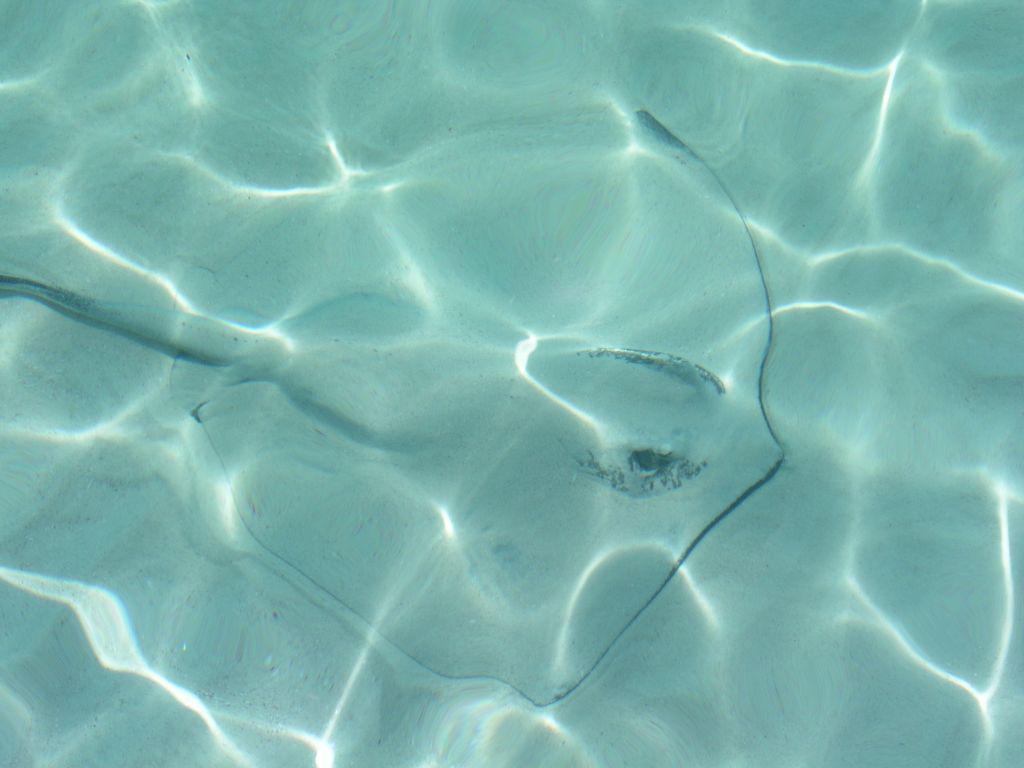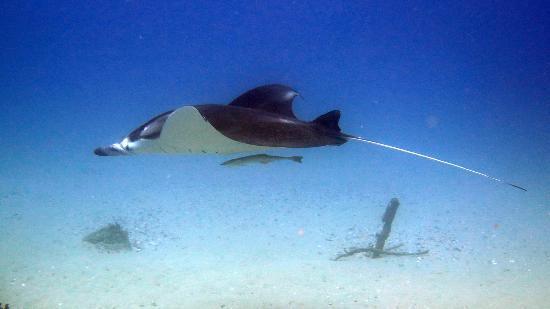The first image is the image on the left, the second image is the image on the right. Analyze the images presented: Is the assertion "Both images include a stingray at the bottom of the ocean." valid? Answer yes or no. No. The first image is the image on the left, the second image is the image on the right. Evaluate the accuracy of this statement regarding the images: "There are more rays in the image on the left than in the image on the right.". Is it true? Answer yes or no. No. 